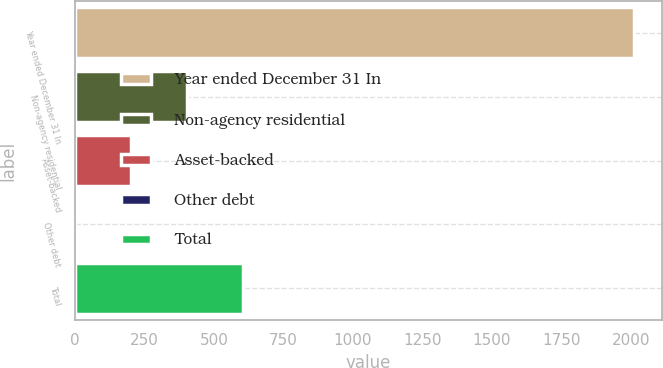<chart> <loc_0><loc_0><loc_500><loc_500><bar_chart><fcel>Year ended December 31 In<fcel>Non-agency residential<fcel>Asset-backed<fcel>Other debt<fcel>Total<nl><fcel>2012<fcel>403.2<fcel>202.1<fcel>1<fcel>604.3<nl></chart> 